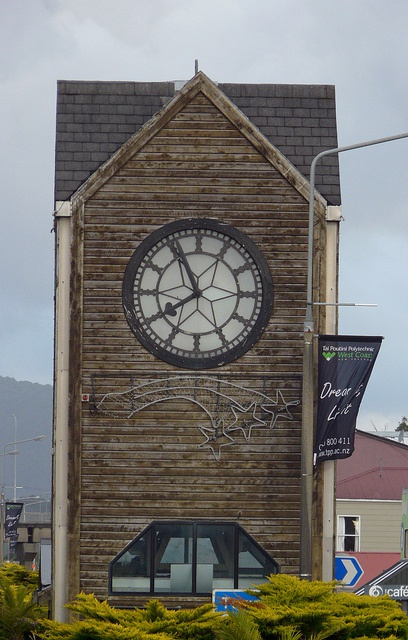Describe the objects in this image and their specific colors. I can see a clock in darkgray, black, and gray tones in this image. 